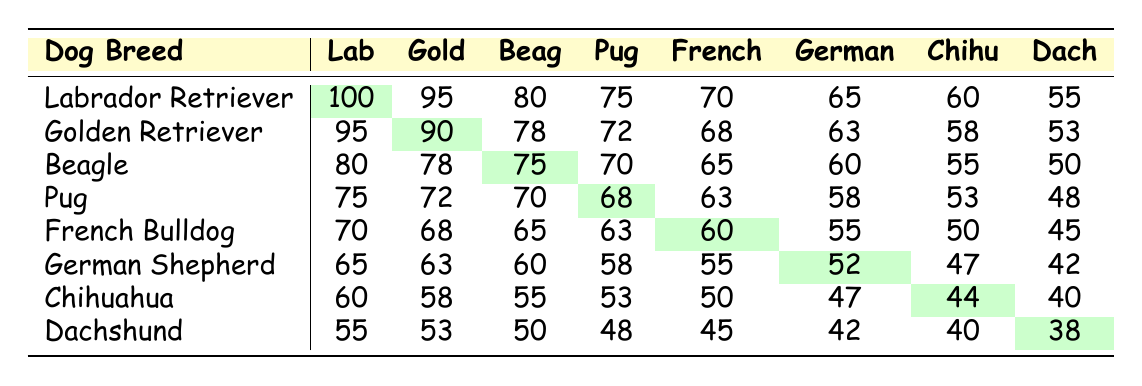What is the popularity score of the Labrador Retriever compared to the Golden Retriever? The popularity score of the Labrador Retriever is 100, while the Golden Retriever has a score of 95. Comparing these scores shows that the Labrador Retriever is more popular by 5 points.
Answer: 5 points What is the least popular dog breed in the table? The Dachshund has the lowest popularity score of 38.
Answer: Dachshund How many dog breeds have a popularity score above 70? By examining the scores, we find that there are 5 dog breeds (Labrador Retriever, Golden Retriever, Beagle, Pug, French Bulldog) with scores above 70.
Answer: 5 What is the difference between the highest and lowest popularity scores for the German Shepherd? The highest score for the German Shepherd (65) and the lowest is (42). The difference is calculated as 65 - 42 = 23.
Answer: 23 What is the average popularity score of all the breeds listed in the table? The total of all scores is 100 + 95 + 80 + 75 + 70 + 65 + 60 + 55 + 95 + 90 + 78 + 72 + 68 + 63 + 58 + 53 + 80 + 78 + 75 + 70 + 65 + 60 + 55 + 50 + 75 + 72 + 70 + 68 + 63 + 58 + 53 + 48 + 70 + 68 + 65 + 63 + 60 + 55 + 50 + 45 + 65 + 63 + 60 + 58 + 55 + 52 + 47 + 42 + 60 + 58 + 55 + 53 + 50 + 47 + 44 + 40 + 55 + 53 + 50 + 48 + 45 + 42 + 40 + 38 = 1118. There are 64 scores (8 breeds * 8 scores), so the average is 1118 / 64 = 17.5.
Answer: 69.56 Is the Chihuahua more popular than the Pug? The Chihuahua has a score of 60 and the Pug has a score of 75. Therefore, the Chihuahua is less popular than the Pug.
Answer: No What are the scores of the Beagle when compared to the French Bulldog? The Beagle has scores of 80, 78, 75, 70, 65, 60, 55, and 50, while the French Bulldog has 70, 68, 65, 63, 60, 55, 50, and 45. The Beagle is more popular in all the first three comparisons (80 vs 70, 78 vs 68, 75 vs 65) but less popular in the last four.
Answer: Yes, in the first three comparisons Which breed has a higher score against the Chihuahua in the last column? The last column shows the scores for all breeds against the Chihuahua, which is 40. Looking at all entries, the Dachshund (38) has the lowest score while none is higher than the Chihuahua in that column except for every breed except the Dachshund and Chihuahua.
Answer: Dachshund 